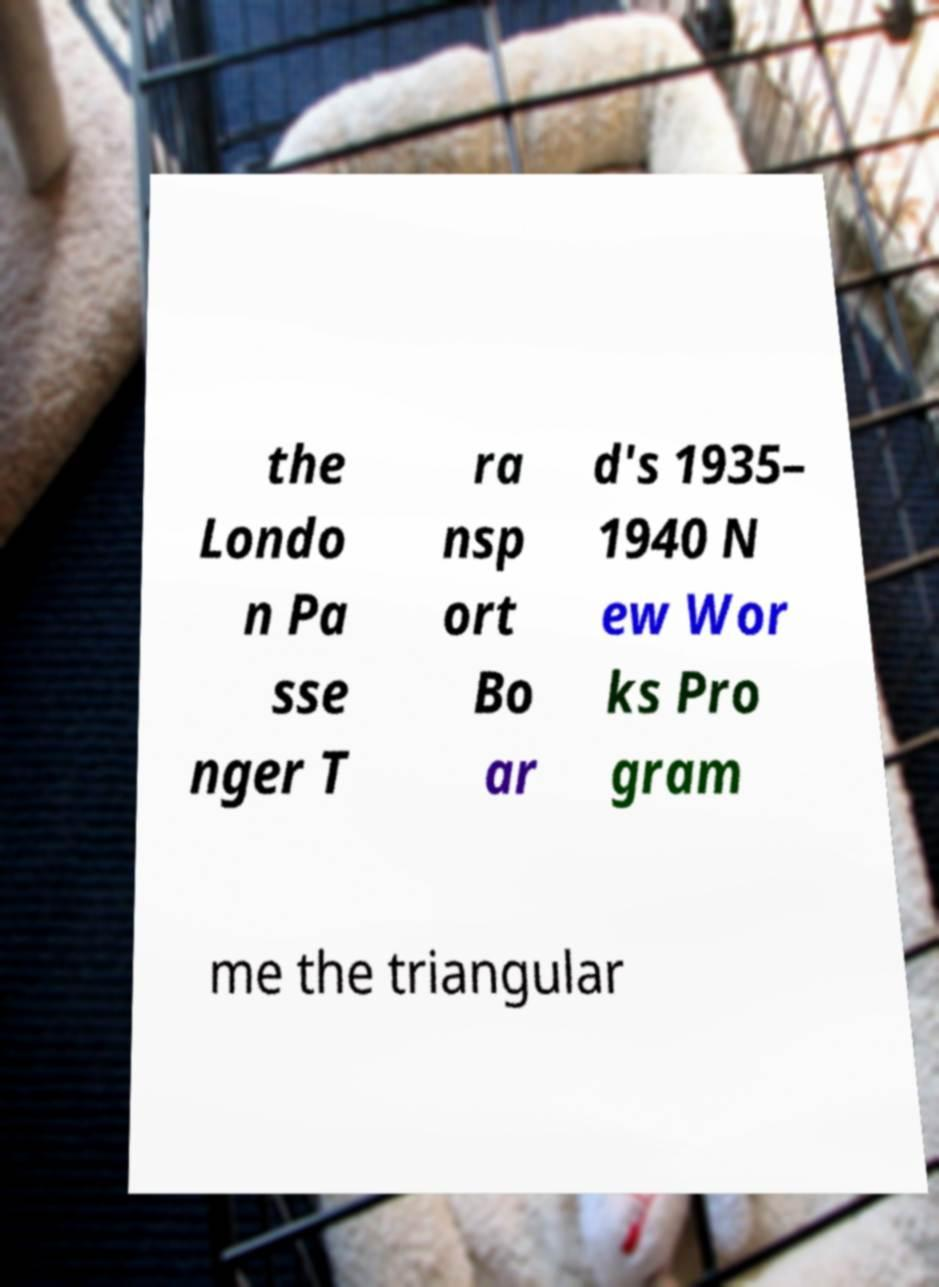There's text embedded in this image that I need extracted. Can you transcribe it verbatim? the Londo n Pa sse nger T ra nsp ort Bo ar d's 1935– 1940 N ew Wor ks Pro gram me the triangular 